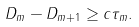Convert formula to latex. <formula><loc_0><loc_0><loc_500><loc_500>D _ { m } - D _ { m + 1 } \geq c \tau _ { m } .</formula> 